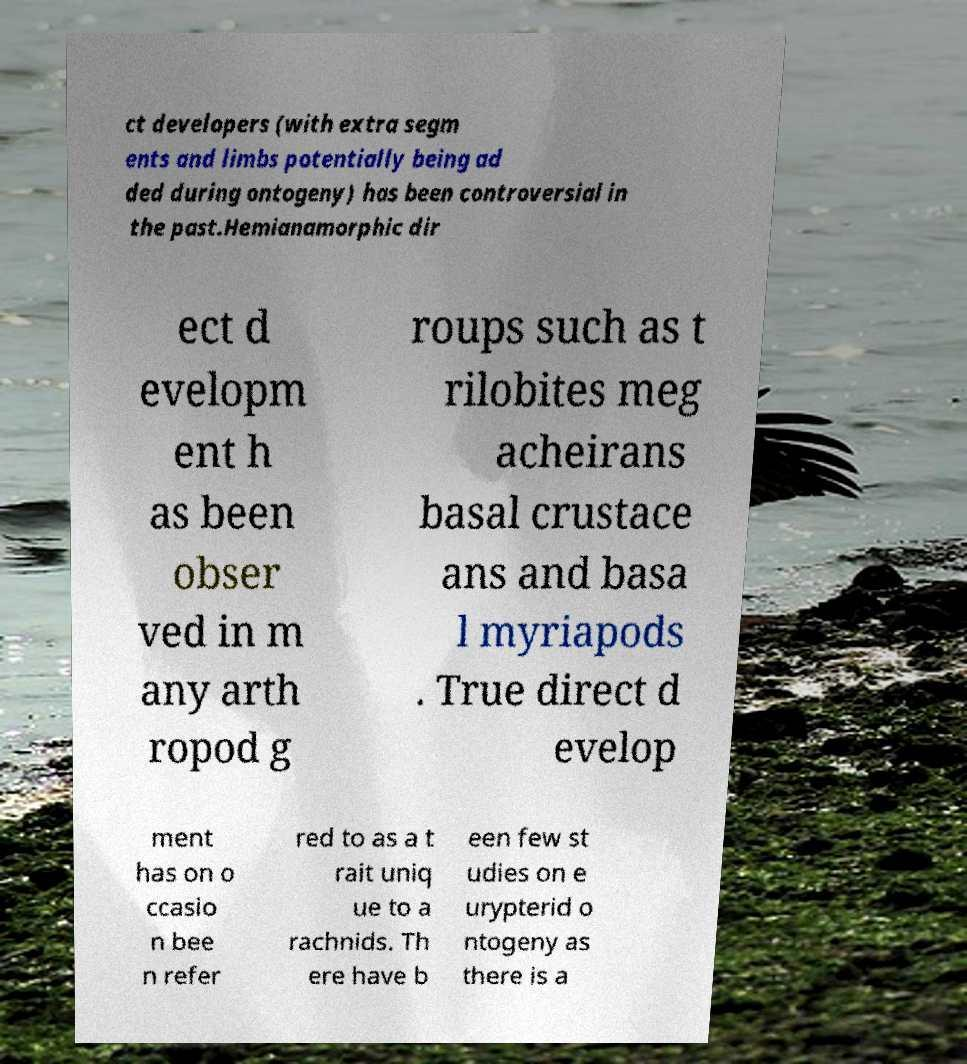Could you assist in decoding the text presented in this image and type it out clearly? ct developers (with extra segm ents and limbs potentially being ad ded during ontogeny) has been controversial in the past.Hemianamorphic dir ect d evelopm ent h as been obser ved in m any arth ropod g roups such as t rilobites meg acheirans basal crustace ans and basa l myriapods . True direct d evelop ment has on o ccasio n bee n refer red to as a t rait uniq ue to a rachnids. Th ere have b een few st udies on e urypterid o ntogeny as there is a 